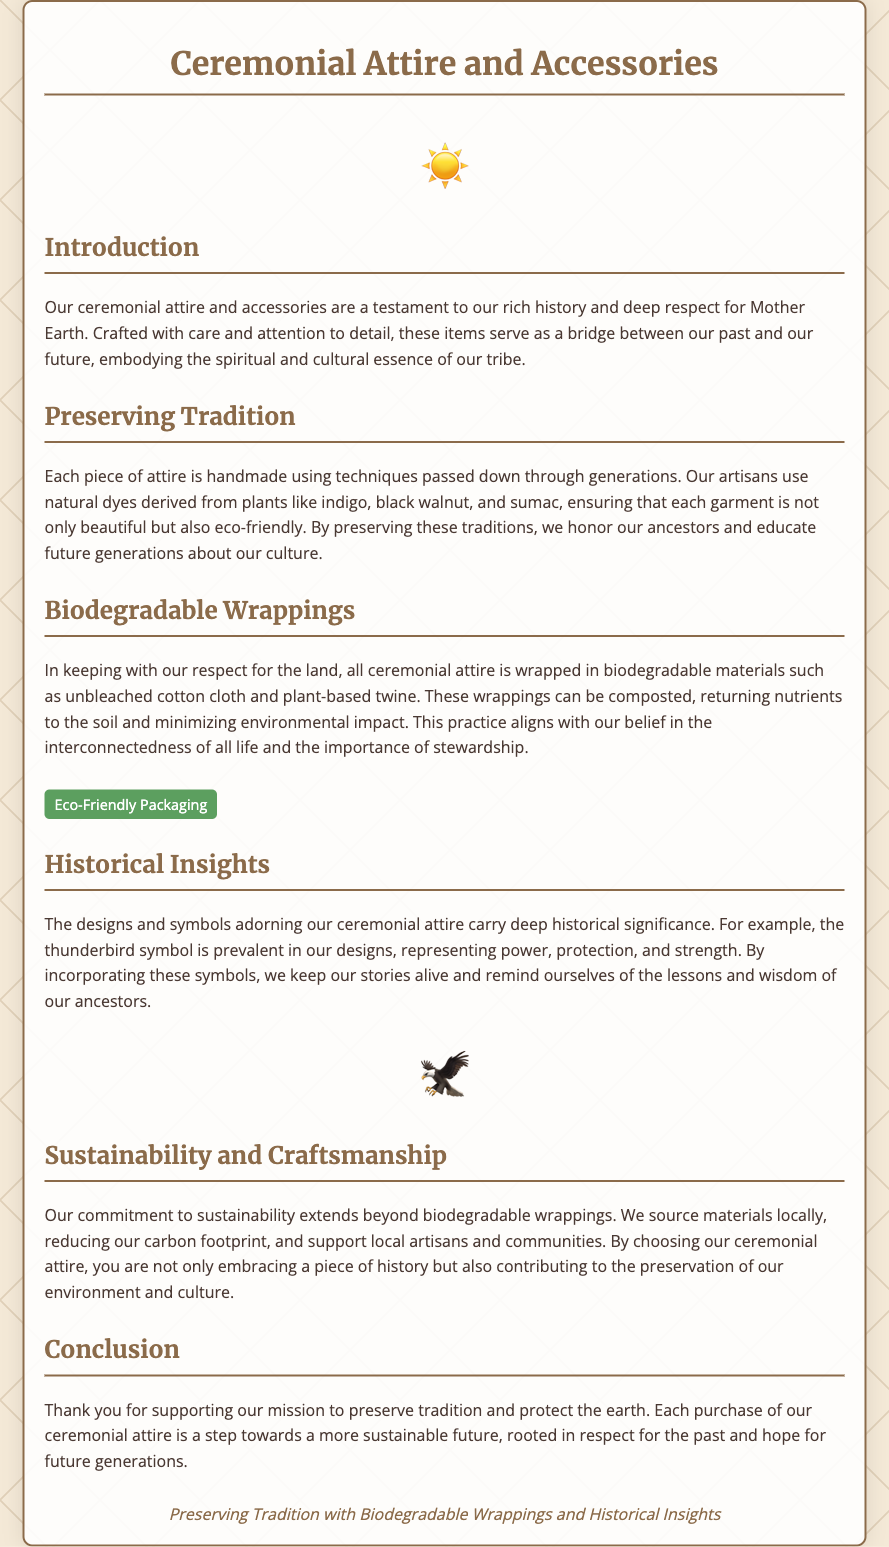What is the main theme of the document? The document focuses on the significance of ceremonial attire and accessories, highlighting traditions, sustainability, and historical insights.
Answer: Preserving Tradition What type of materials are used for wrapping the attire? The document mentions biodegradable materials, specifically types of cloth and twine used for wrapping.
Answer: Unbleached cotton cloth and plant-based twine What cultural symbol is prevalent in the designs? The document provides insight into symbols used in the attire and their meanings, pointing out one specific symbol.
Answer: Thunderbird Who crafts the ceremonial attire? The document describes the artisans involved in creating the attire, emphasizing their skills and heritage.
Answer: Local artisans What is one natural dye mentioned in the document? The document lists various natural dyes used in the traditional crafts, and one example is specifically named.
Answer: Indigo How does the document describe the impact of biodegradable wrappings? The document explains the environmental benefits of the materials used for wrapping the attire, highlighting a specific outcome.
Answer: Returning nutrients to the soil What are buyers contributing to by purchasing the attire? The document outlines the societal impact of the purchase of ceremonial attire, indicating a broader contribution.
Answer: Preservation of our environment and culture What is the purpose of the eco-label? The document includes an eco-label to underscore a specific aspect of the packaging, focusing on environmental friendliness.
Answer: Eco-Friendly Packaging What is the connection made between past and future in the document? The document outlines the way traditions and practices link the historical aspects of the tribe to current practices.
Answer: A bridge between our past and our future 